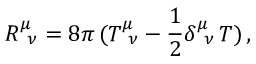<formula> <loc_0><loc_0><loc_500><loc_500>R _ { \, \nu } ^ { \mu } = 8 \pi \, ( T _ { \, \nu } ^ { \mu } - \frac { 1 } { 2 } \delta _ { \, \nu } ^ { \mu } \, T ) \, ,</formula> 